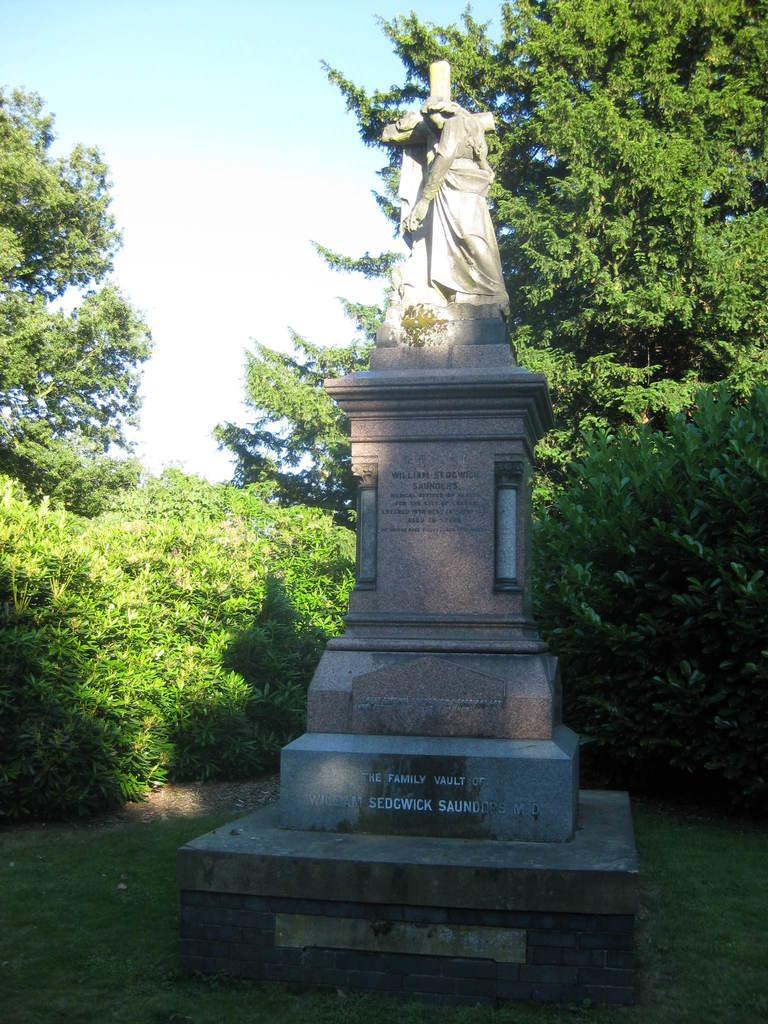What is the main subject of the image? There is a sculpture in the image. What can be seen in the background of the image? There are trees and the sky visible in the background of the image. What type of caption is written on the jar in the image? There is no jar present in the image, so there is no caption to be read. 